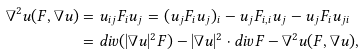Convert formula to latex. <formula><loc_0><loc_0><loc_500><loc_500>\nabla ^ { 2 } u ( F , \nabla u ) & = u _ { i j } F _ { i } u _ { j } = ( u _ { j } F _ { i } u _ { j } ) _ { i } - u _ { j } F _ { i , i } u _ { j } - u _ { j } F _ { i } u _ { j i } \\ & = d i v ( | \nabla u | ^ { 2 } F ) - | \nabla u | ^ { 2 } \cdot d i v F - \nabla ^ { 2 } u ( F , \nabla u ) ,</formula> 